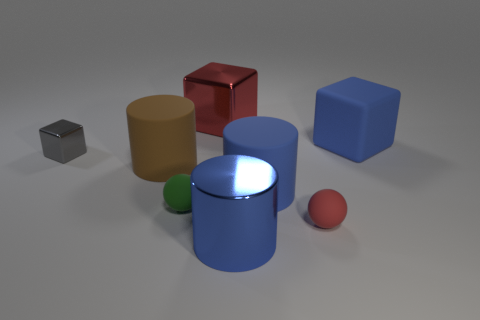Subtract all big cubes. How many cubes are left? 1 Subtract 1 cylinders. How many cylinders are left? 2 Subtract all yellow blocks. How many blue cylinders are left? 2 Add 1 balls. How many objects exist? 9 Subtract all cubes. How many objects are left? 5 Subtract 0 gray spheres. How many objects are left? 8 Subtract all rubber balls. Subtract all tiny green metallic objects. How many objects are left? 6 Add 4 large blue metal cylinders. How many large blue metal cylinders are left? 5 Add 6 large rubber cylinders. How many large rubber cylinders exist? 8 